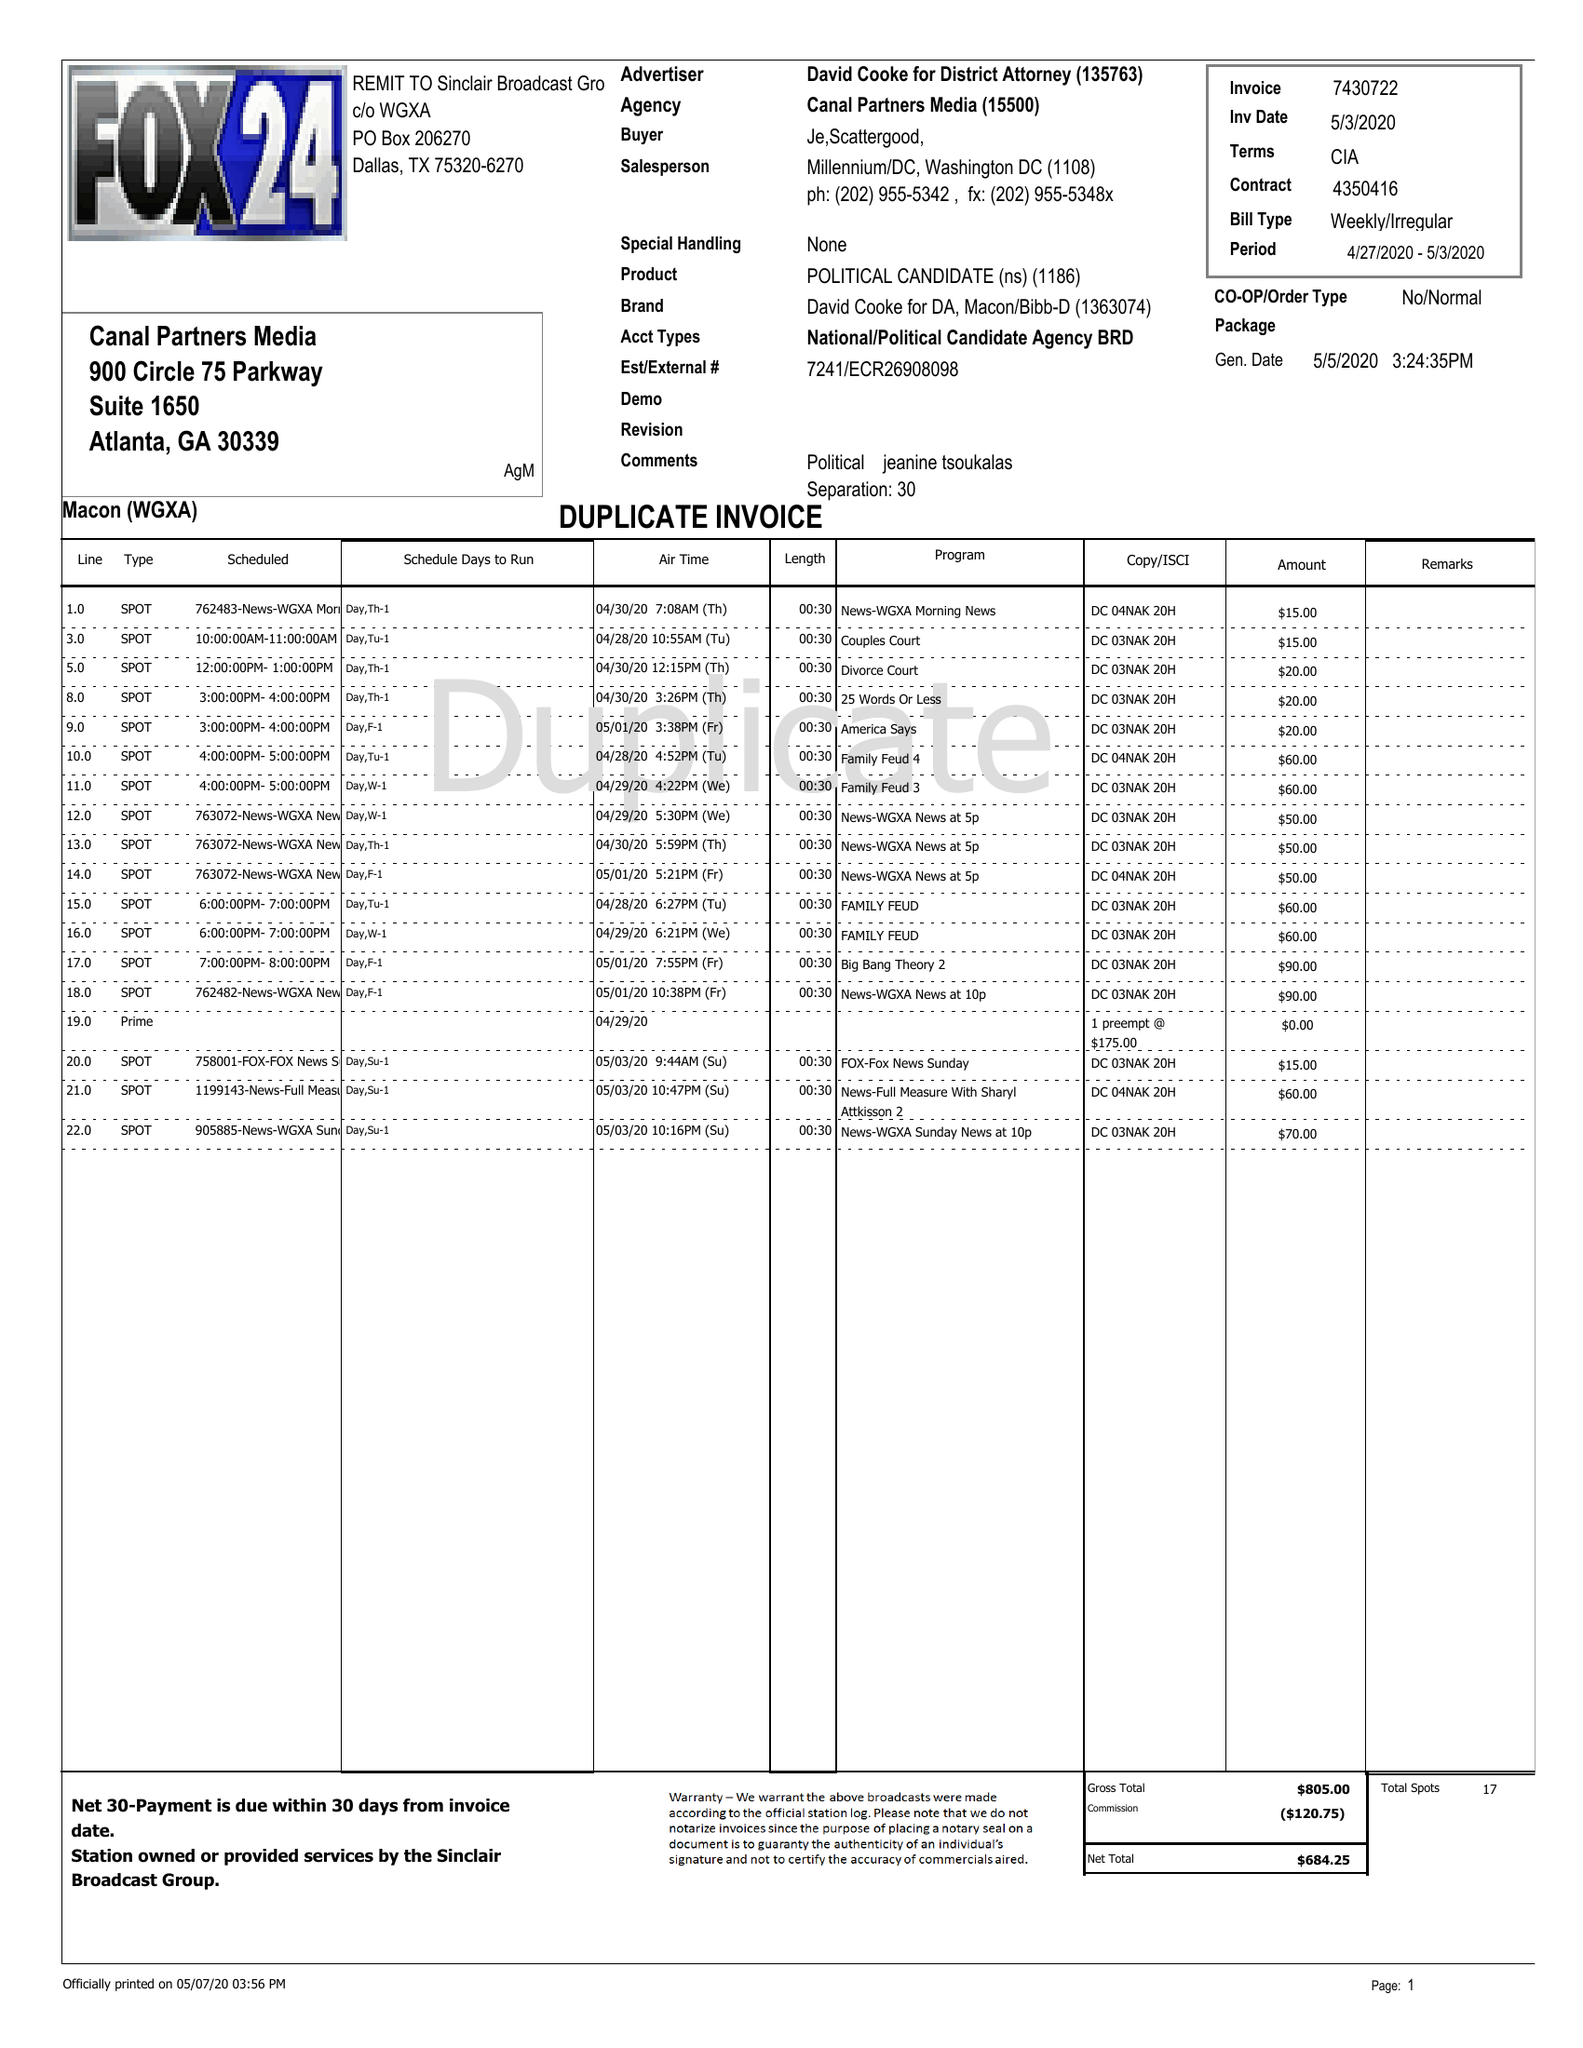What is the value for the flight_to?
Answer the question using a single word or phrase. 05/03/20 